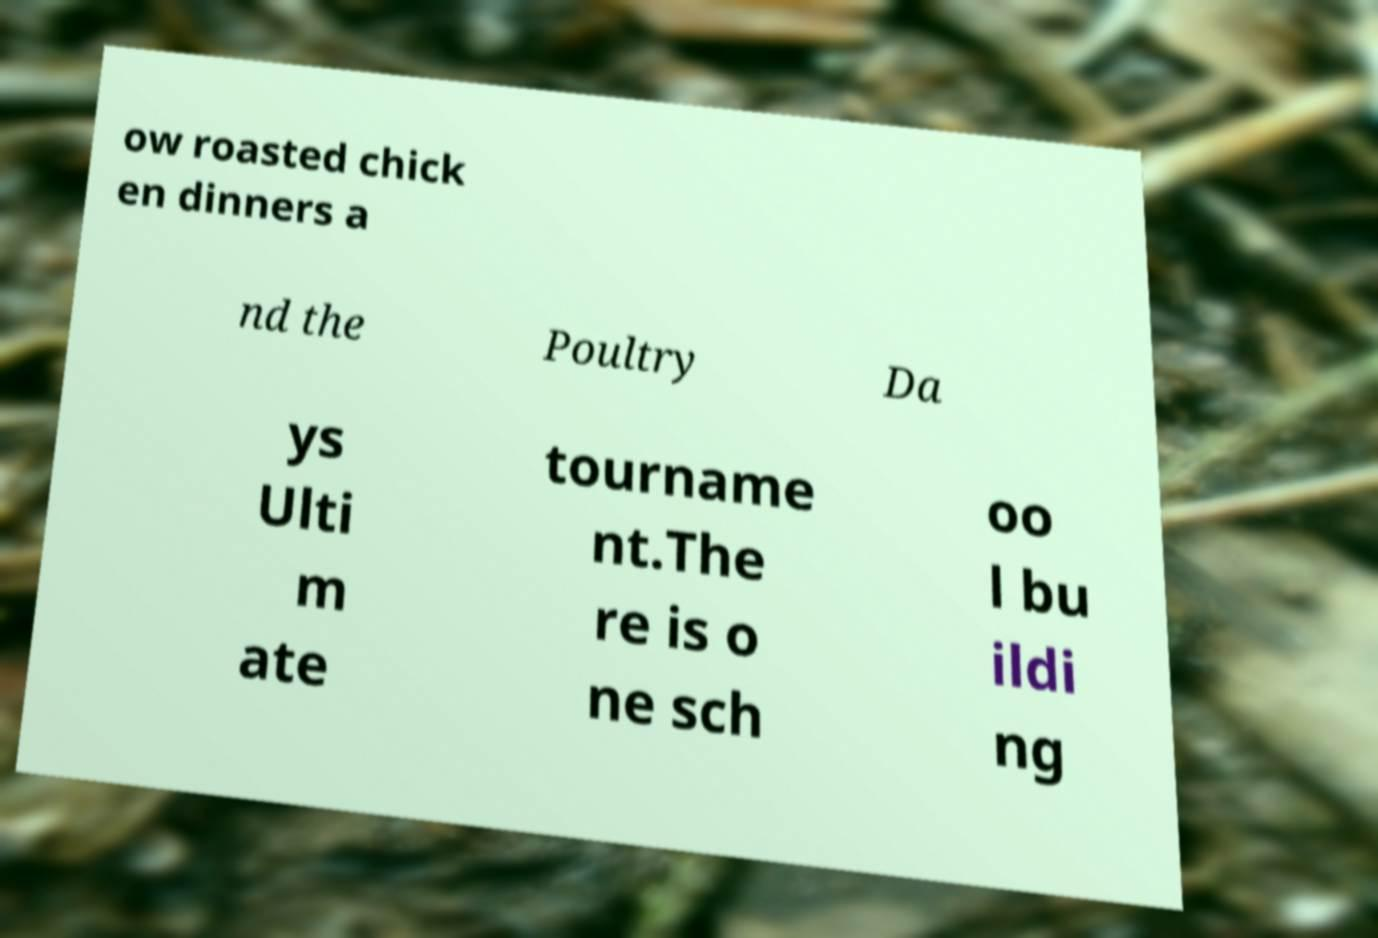For documentation purposes, I need the text within this image transcribed. Could you provide that? ow roasted chick en dinners a nd the Poultry Da ys Ulti m ate tourname nt.The re is o ne sch oo l bu ildi ng 